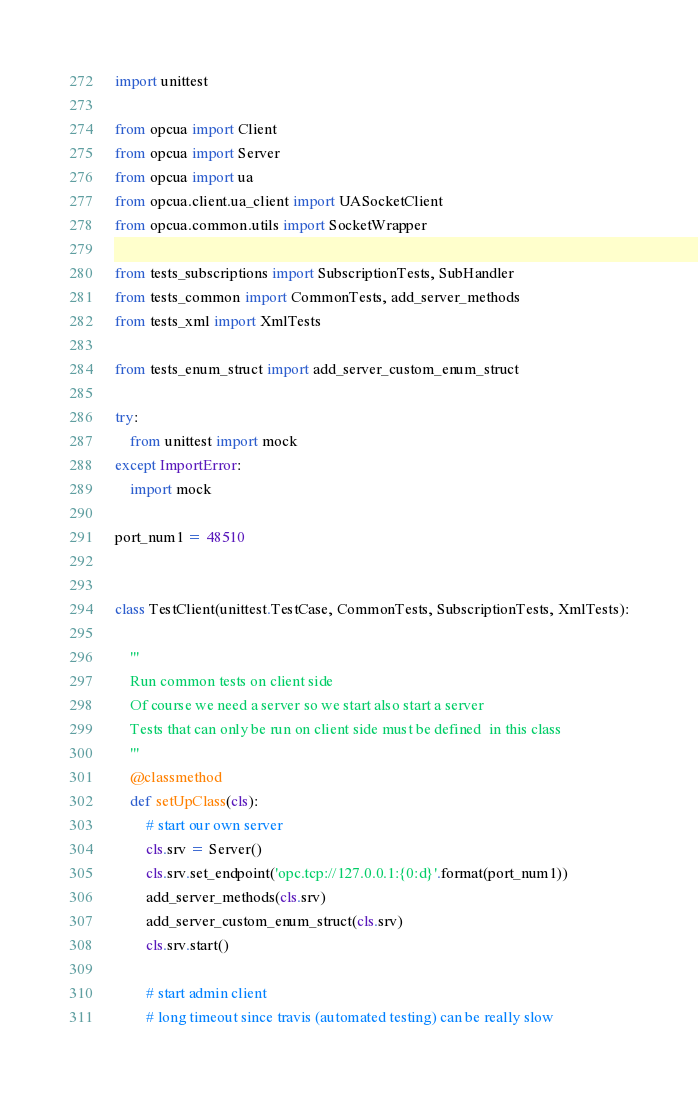<code> <loc_0><loc_0><loc_500><loc_500><_Python_>import unittest

from opcua import Client
from opcua import Server
from opcua import ua
from opcua.client.ua_client import UASocketClient
from opcua.common.utils import SocketWrapper

from tests_subscriptions import SubscriptionTests, SubHandler
from tests_common import CommonTests, add_server_methods
from tests_xml import XmlTests

from tests_enum_struct import add_server_custom_enum_struct

try:
    from unittest import mock
except ImportError:
    import mock

port_num1 = 48510


class TestClient(unittest.TestCase, CommonTests, SubscriptionTests, XmlTests):

    '''
    Run common tests on client side
    Of course we need a server so we start also start a server
    Tests that can only be run on client side must be defined  in this class
    '''
    @classmethod
    def setUpClass(cls):
        # start our own server
        cls.srv = Server()
        cls.srv.set_endpoint('opc.tcp://127.0.0.1:{0:d}'.format(port_num1))
        add_server_methods(cls.srv)
        add_server_custom_enum_struct(cls.srv)
        cls.srv.start()

        # start admin client
        # long timeout since travis (automated testing) can be really slow</code> 